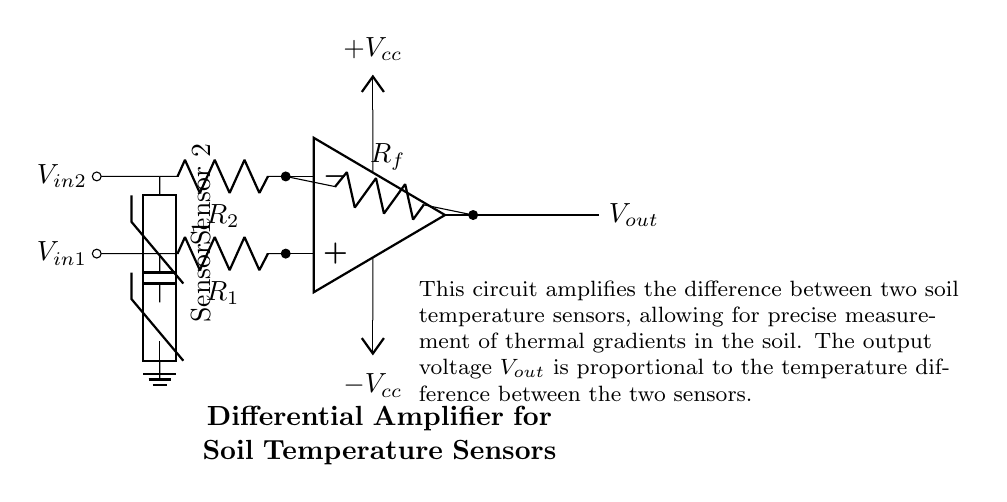What type of amplifier is shown in the circuit? The circuit diagram depicts a differential amplifier, which is characterized by its ability to amplify the difference between two input signals.
Answer: differential amplifier What do the two thermistors represent? The two thermistors in the circuit serve as temperature sensors. They detect and measure the soil temperature at two different locations, providing the necessary input to the differential amplifier.
Answer: temperature sensors What is the output voltage for this amplifier based on the input? The output voltage, represented as Vout, is proportional to the temperature difference between the inputs V in1 and V in2, multiplied by the gain determined by the resistor values in the circuit.
Answer: Vout What do the resistors R1 and R2 do in this circuit? Resistors R1 and R2 are input resistors that help set the gain of the amplifier and establish the relationship between the input voltage signals and the output voltage.
Answer: set gain How is the differential amplifier powered? The circuit is powered by an external dual power supply, providing positive voltage Vcc and negative voltage Vee to the operational amplifier, allowing it to function effectively.
Answer: dual power supply What is the function of the feedback resistor Rf? The feedback resistor Rf in this differential amplifier configuration defines the feedback loop, determining the overall gain and stability of the amplifier circuit.
Answer: defines gain What does the ground symbol indicate in the circuit? The ground symbol signifies the reference point in the circuit where the input voltage measurements are taken, establishing a common return path for current flow.
Answer: reference point 